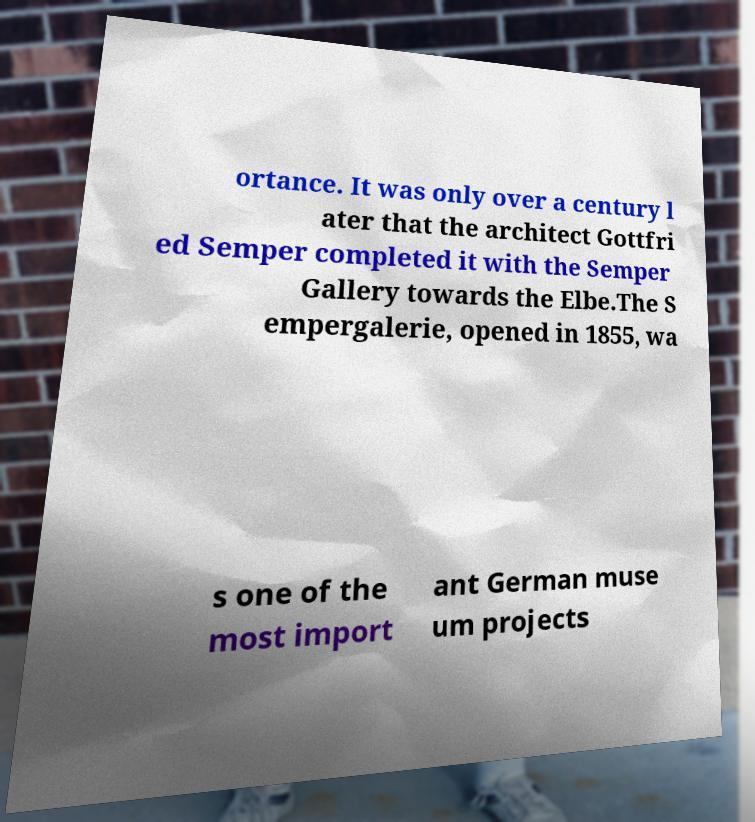What messages or text are displayed in this image? I need them in a readable, typed format. ortance. It was only over a century l ater that the architect Gottfri ed Semper completed it with the Semper Gallery towards the Elbe.The S empergalerie, opened in 1855, wa s one of the most import ant German muse um projects 